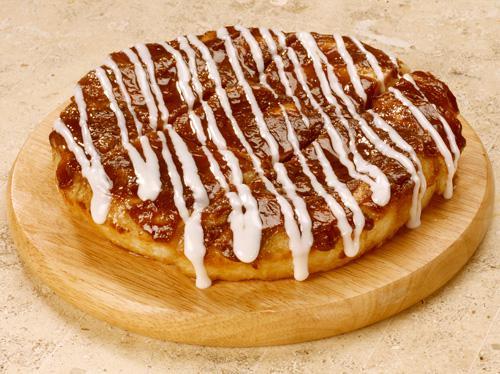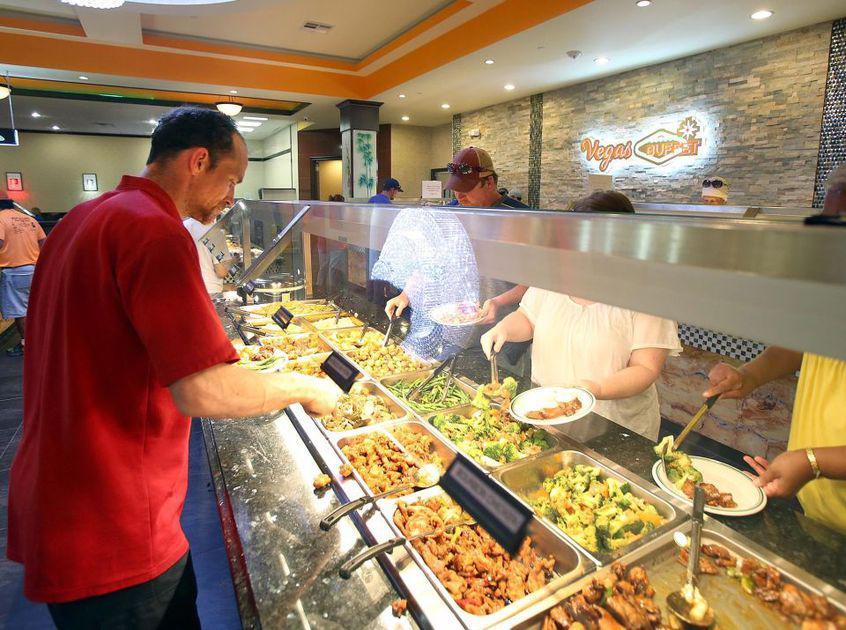The first image is the image on the left, the second image is the image on the right. Considering the images on both sides, is "People stand along a buffet in one of the images." valid? Answer yes or no. Yes. 